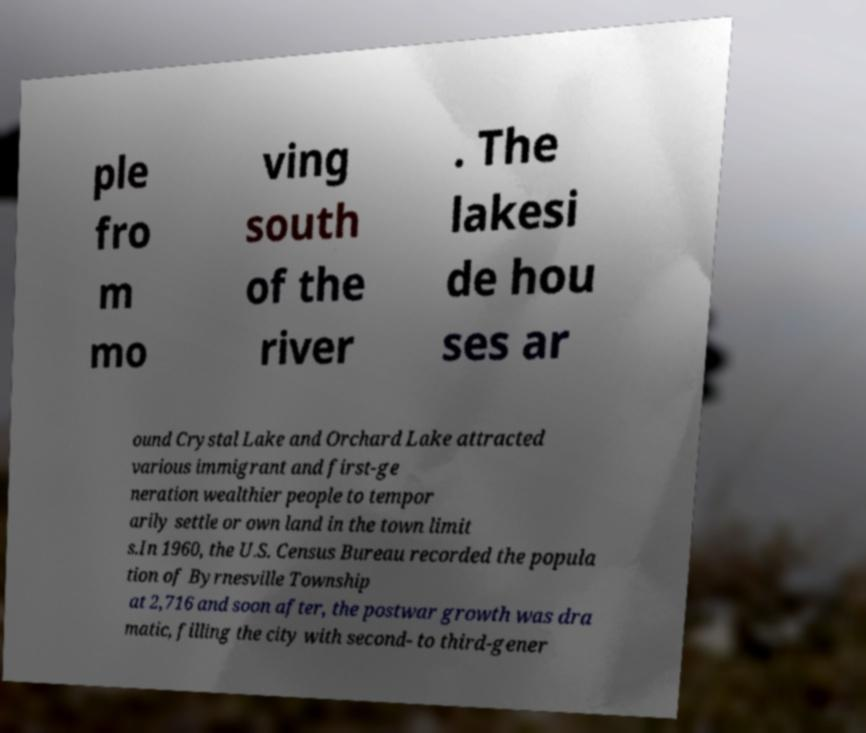Please read and relay the text visible in this image. What does it say? ple fro m mo ving south of the river . The lakesi de hou ses ar ound Crystal Lake and Orchard Lake attracted various immigrant and first-ge neration wealthier people to tempor arily settle or own land in the town limit s.In 1960, the U.S. Census Bureau recorded the popula tion of Byrnesville Township at 2,716 and soon after, the postwar growth was dra matic, filling the city with second- to third-gener 